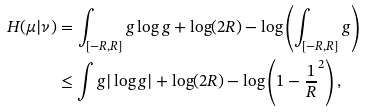Convert formula to latex. <formula><loc_0><loc_0><loc_500><loc_500>H ( \mu | \nu ) & = \int _ { [ - R , R ] } g \log g + \log ( 2 R ) - \log \left ( \int _ { [ - R , R ] } g \right ) \\ & \leq \int g | \log g | + \log ( 2 R ) - \log \left ( 1 - \frac { 1 } { R } ^ { 2 } \right ) ,</formula> 